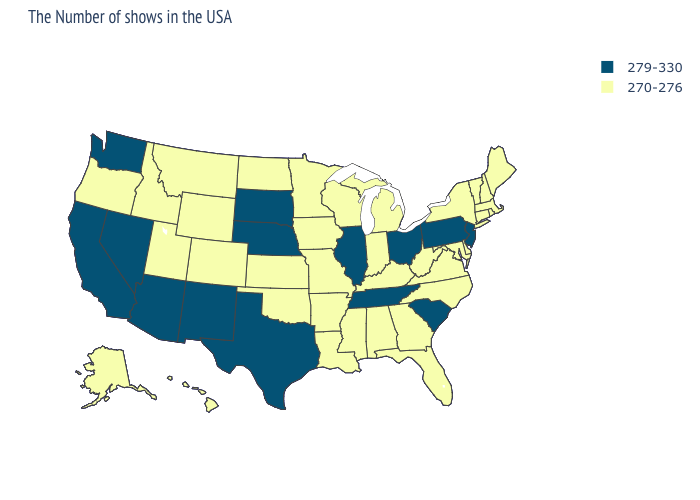What is the value of Minnesota?
Write a very short answer. 270-276. What is the value of South Carolina?
Write a very short answer. 279-330. Name the states that have a value in the range 270-276?
Short answer required. Maine, Massachusetts, Rhode Island, New Hampshire, Vermont, Connecticut, New York, Delaware, Maryland, Virginia, North Carolina, West Virginia, Florida, Georgia, Michigan, Kentucky, Indiana, Alabama, Wisconsin, Mississippi, Louisiana, Missouri, Arkansas, Minnesota, Iowa, Kansas, Oklahoma, North Dakota, Wyoming, Colorado, Utah, Montana, Idaho, Oregon, Alaska, Hawaii. Among the states that border South Dakota , which have the lowest value?
Short answer required. Minnesota, Iowa, North Dakota, Wyoming, Montana. What is the value of New York?
Write a very short answer. 270-276. Does Alaska have a higher value than Connecticut?
Give a very brief answer. No. What is the lowest value in the West?
Concise answer only. 270-276. Does New Mexico have the same value as West Virginia?
Concise answer only. No. Does the map have missing data?
Write a very short answer. No. What is the value of New Jersey?
Keep it brief. 279-330. What is the highest value in states that border New Jersey?
Short answer required. 279-330. Among the states that border New Jersey , which have the lowest value?
Quick response, please. New York, Delaware. Which states have the highest value in the USA?
Write a very short answer. New Jersey, Pennsylvania, South Carolina, Ohio, Tennessee, Illinois, Nebraska, Texas, South Dakota, New Mexico, Arizona, Nevada, California, Washington. What is the lowest value in the MidWest?
Be succinct. 270-276. Name the states that have a value in the range 279-330?
Write a very short answer. New Jersey, Pennsylvania, South Carolina, Ohio, Tennessee, Illinois, Nebraska, Texas, South Dakota, New Mexico, Arizona, Nevada, California, Washington. 